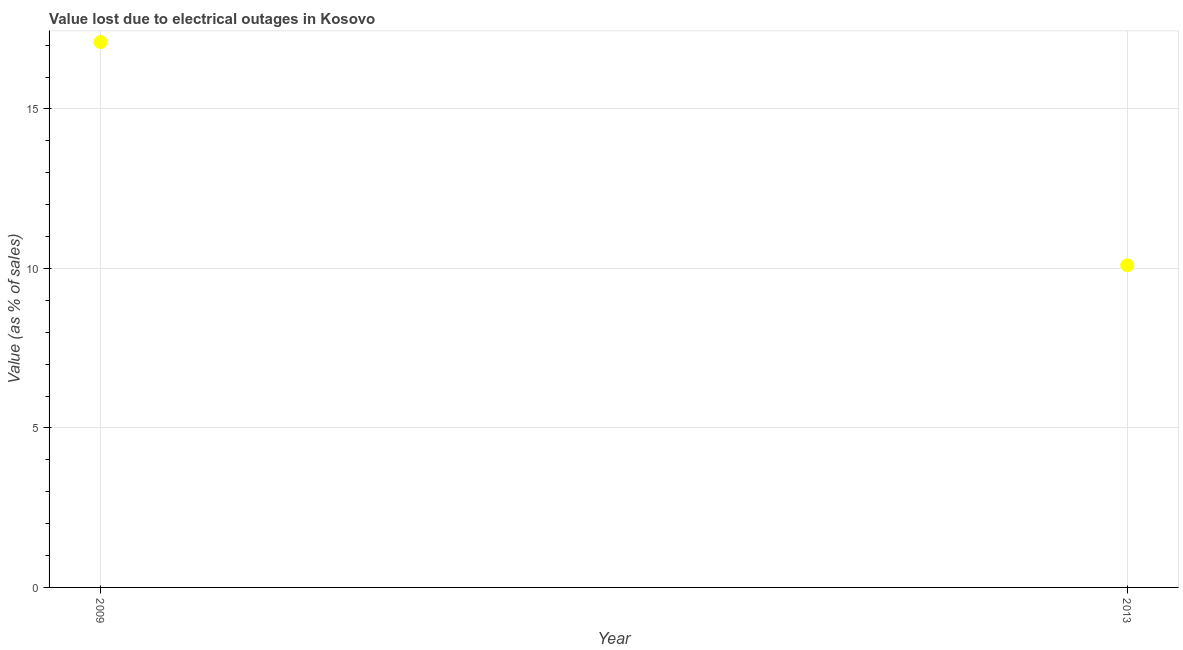What is the value lost due to electrical outages in 2013?
Provide a succinct answer. 10.1. Across all years, what is the maximum value lost due to electrical outages?
Make the answer very short. 17.1. Across all years, what is the minimum value lost due to electrical outages?
Give a very brief answer. 10.1. In which year was the value lost due to electrical outages minimum?
Your answer should be very brief. 2013. What is the sum of the value lost due to electrical outages?
Your response must be concise. 27.2. What is the difference between the value lost due to electrical outages in 2009 and 2013?
Make the answer very short. 7. What is the average value lost due to electrical outages per year?
Ensure brevity in your answer.  13.6. What is the median value lost due to electrical outages?
Give a very brief answer. 13.6. What is the ratio of the value lost due to electrical outages in 2009 to that in 2013?
Your answer should be very brief. 1.69. In how many years, is the value lost due to electrical outages greater than the average value lost due to electrical outages taken over all years?
Your answer should be compact. 1. How many years are there in the graph?
Your answer should be very brief. 2. Are the values on the major ticks of Y-axis written in scientific E-notation?
Ensure brevity in your answer.  No. Does the graph contain grids?
Your answer should be very brief. Yes. What is the title of the graph?
Your answer should be compact. Value lost due to electrical outages in Kosovo. What is the label or title of the X-axis?
Give a very brief answer. Year. What is the label or title of the Y-axis?
Keep it short and to the point. Value (as % of sales). What is the Value (as % of sales) in 2013?
Provide a short and direct response. 10.1. What is the difference between the Value (as % of sales) in 2009 and 2013?
Provide a short and direct response. 7. What is the ratio of the Value (as % of sales) in 2009 to that in 2013?
Offer a terse response. 1.69. 